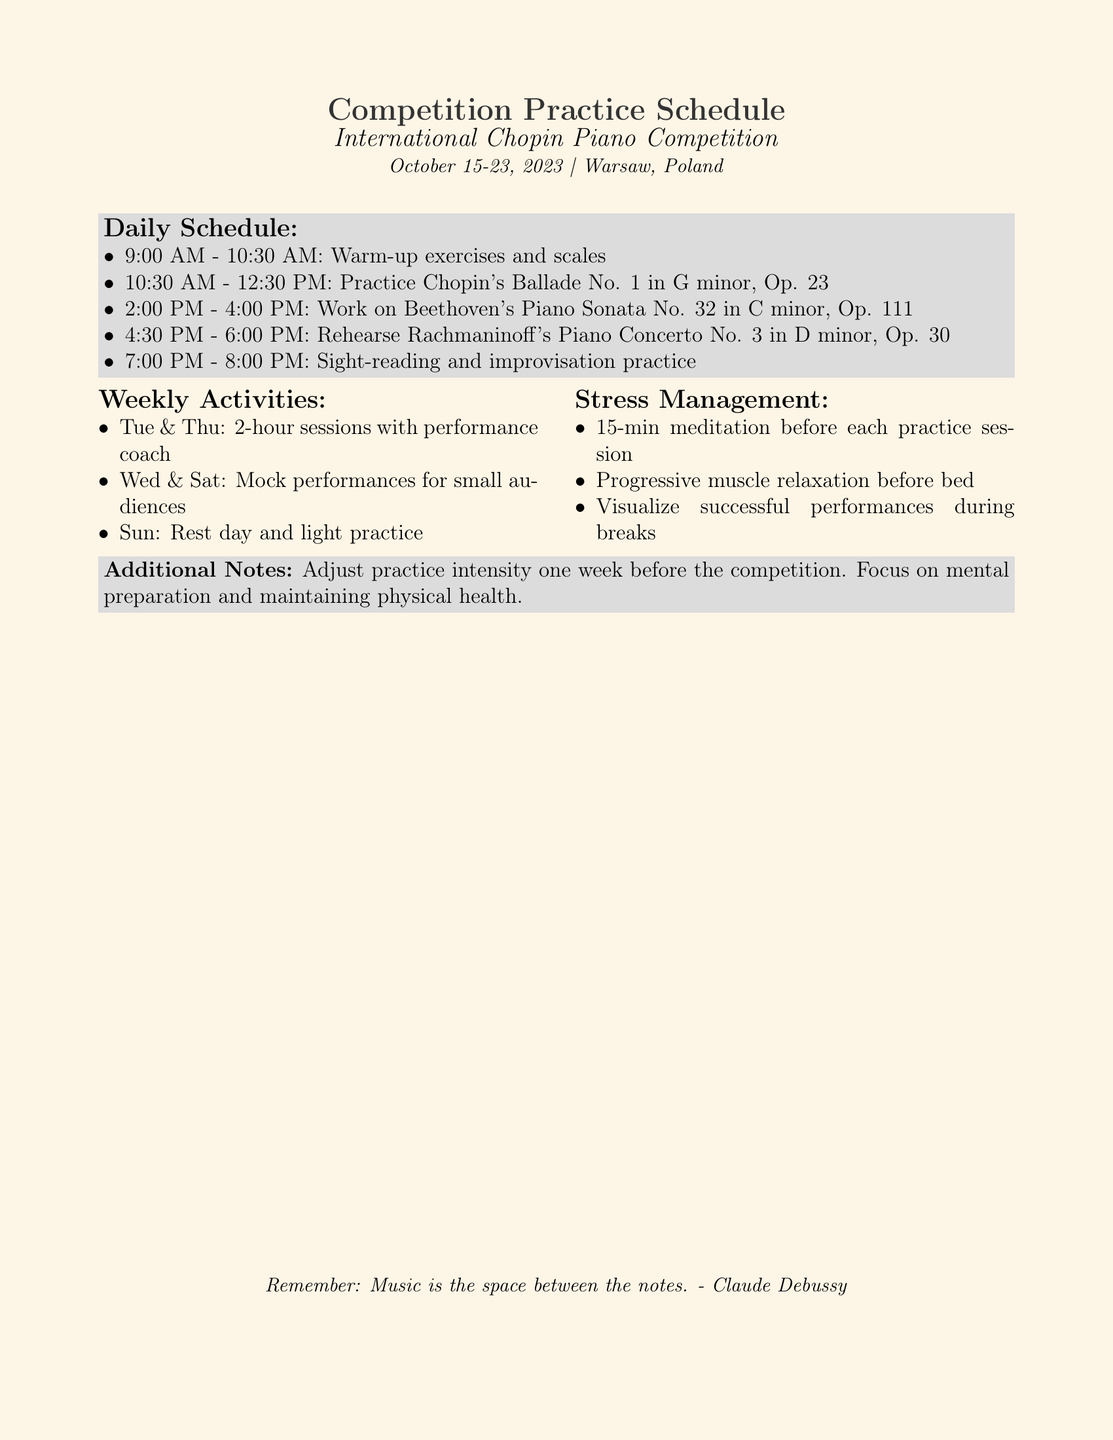What is the title of the competition? The title of the competition is stated at the top of the document.
Answer: International Chopin Piano Competition What is the date range of the competition? The date range is provided in the introductory text of the document.
Answer: October 15-23, 2023 What piece is practiced from 10:30 AM to 12:30 PM? This information is found in the daily schedule section regarding practice times and pieces.
Answer: Chopin's Ballade No. 1 in G minor, Op. 23 How long are the warm-up exercises scheduled? The duration of the warm-up exercises is specified in the daily schedule.
Answer: 1.5 hours Which two days are designated for mock performances? This is detailed in the weekly activities section of the document.
Answer: Wednesday & Saturday What stress management technique is mentioned for practice sessions? The document lists a specific stress management approach before each practice session.
Answer: 15-min meditation How many hours are the sessions with the performance coach? This information is found in the weekly activities section discussing performance coaching.
Answer: 2 hours What day is allocated as a rest day? The rest day is explicitly cited in the weekly activities section.
Answer: Sunday What piece is rehearsed from 4:30 PM to 6:00 PM? This can be found in the daily schedule detailing specific practice pieces and times.
Answer: Rachmaninoff's Piano Concerto No. 3 in D minor, Op. 30 